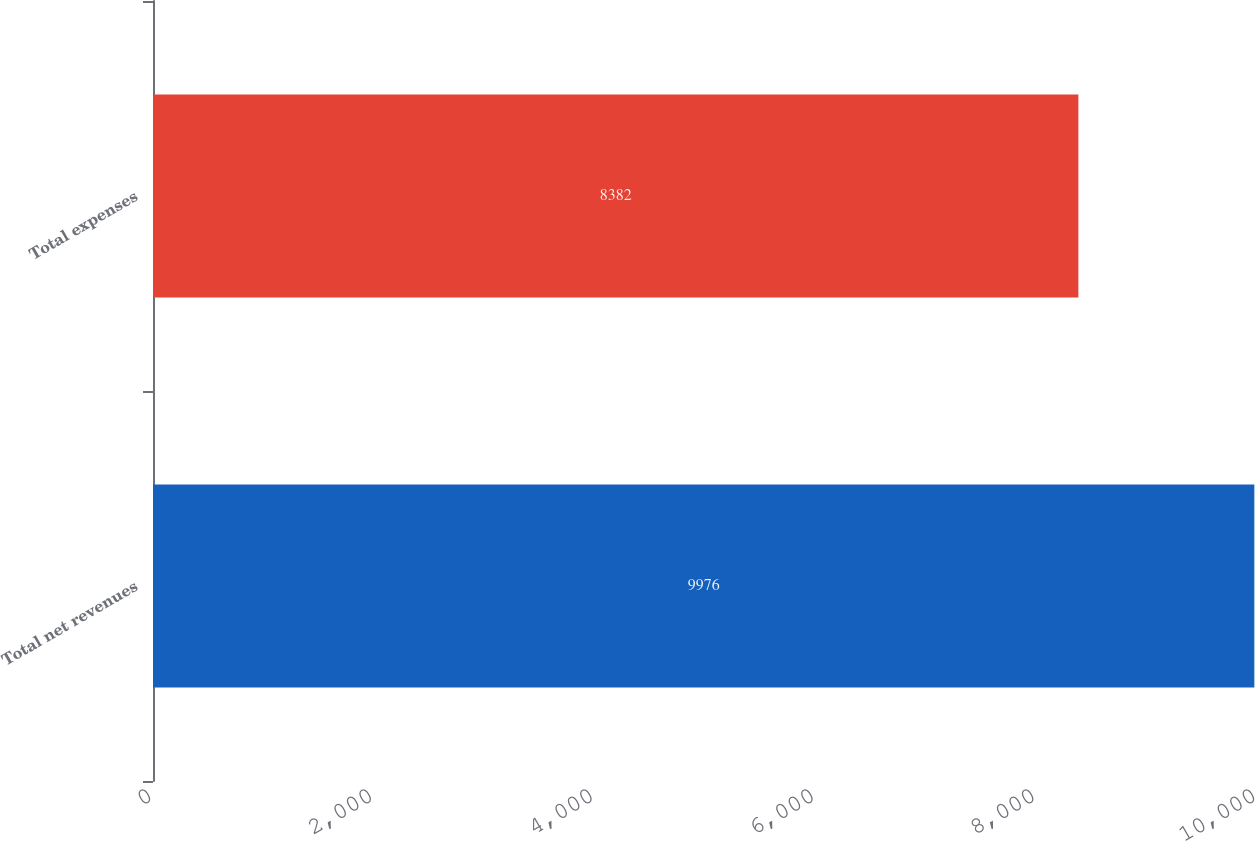Convert chart. <chart><loc_0><loc_0><loc_500><loc_500><bar_chart><fcel>Total net revenues<fcel>Total expenses<nl><fcel>9976<fcel>8382<nl></chart> 